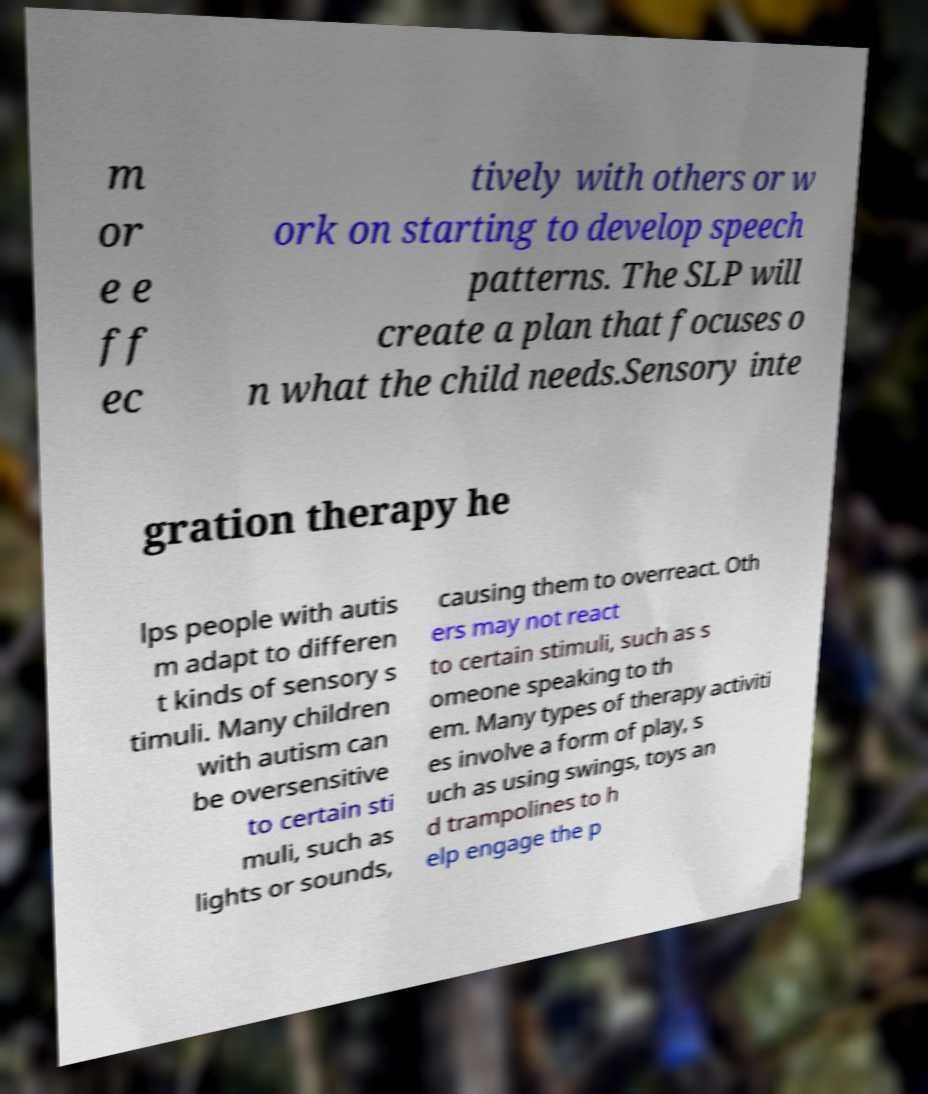Could you assist in decoding the text presented in this image and type it out clearly? m or e e ff ec tively with others or w ork on starting to develop speech patterns. The SLP will create a plan that focuses o n what the child needs.Sensory inte gration therapy he lps people with autis m adapt to differen t kinds of sensory s timuli. Many children with autism can be oversensitive to certain sti muli, such as lights or sounds, causing them to overreact. Oth ers may not react to certain stimuli, such as s omeone speaking to th em. Many types of therapy activiti es involve a form of play, s uch as using swings, toys an d trampolines to h elp engage the p 